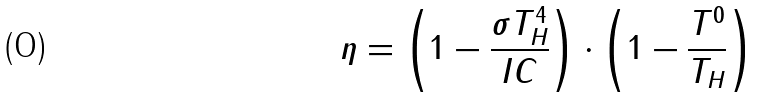<formula> <loc_0><loc_0><loc_500><loc_500>\eta = \left ( 1 - { \frac { \sigma T _ { H } ^ { 4 } } { I C } } \right ) \cdot \left ( 1 - { \frac { T ^ { 0 } } { T _ { H } } } \right )</formula> 